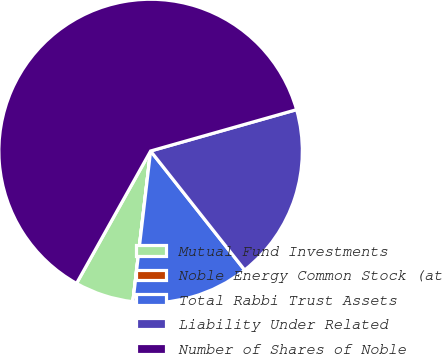Convert chart. <chart><loc_0><loc_0><loc_500><loc_500><pie_chart><fcel>Mutual Fund Investments<fcel>Noble Energy Common Stock (at<fcel>Total Rabbi Trust Assets<fcel>Liability Under Related<fcel>Number of Shares of Noble<nl><fcel>6.25%<fcel>0.01%<fcel>12.5%<fcel>18.75%<fcel>62.49%<nl></chart> 